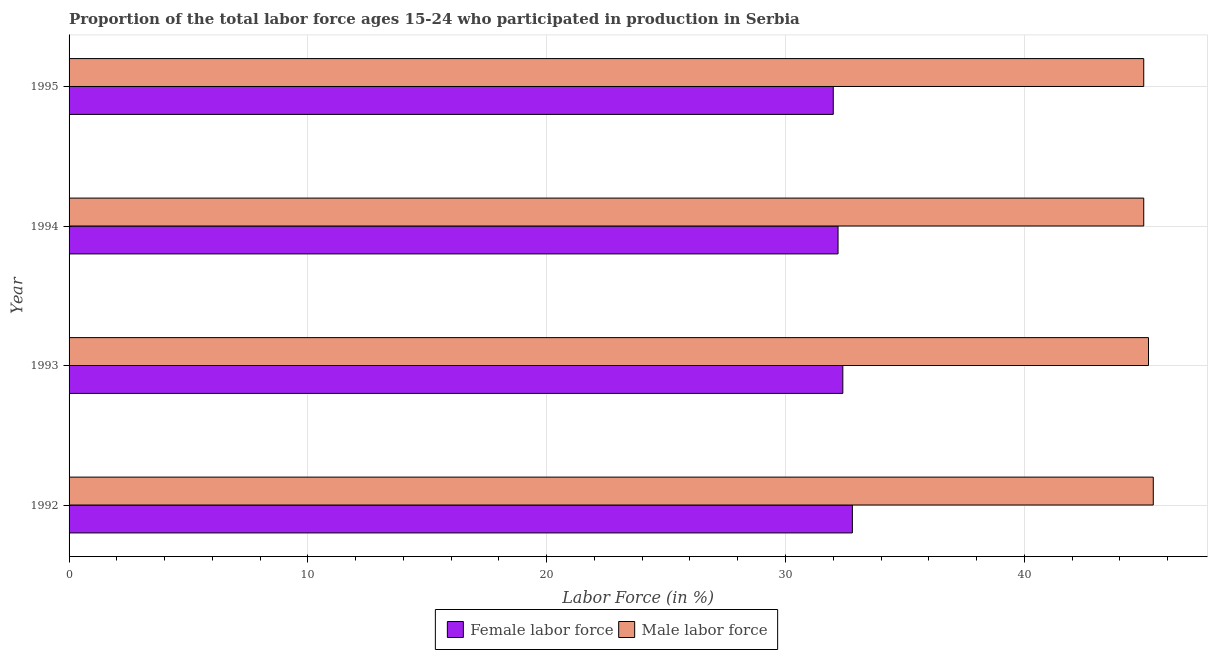How many groups of bars are there?
Keep it short and to the point. 4. Are the number of bars on each tick of the Y-axis equal?
Provide a succinct answer. Yes. How many bars are there on the 1st tick from the top?
Provide a short and direct response. 2. What is the percentage of male labour force in 1995?
Keep it short and to the point. 45. Across all years, what is the maximum percentage of female labor force?
Give a very brief answer. 32.8. Across all years, what is the minimum percentage of male labour force?
Ensure brevity in your answer.  45. What is the total percentage of male labour force in the graph?
Offer a terse response. 180.6. What is the difference between the percentage of male labour force in 1993 and that in 1994?
Your answer should be compact. 0.2. What is the difference between the percentage of female labor force in 1992 and the percentage of male labour force in 1995?
Provide a short and direct response. -12.2. What is the average percentage of female labor force per year?
Your answer should be compact. 32.35. In the year 1994, what is the difference between the percentage of female labor force and percentage of male labour force?
Your answer should be compact. -12.8. In how many years, is the percentage of male labour force greater than 10 %?
Ensure brevity in your answer.  4. Is the difference between the percentage of male labour force in 1994 and 1995 greater than the difference between the percentage of female labor force in 1994 and 1995?
Your answer should be very brief. No. What is the difference between the highest and the second highest percentage of female labor force?
Your answer should be very brief. 0.4. In how many years, is the percentage of male labour force greater than the average percentage of male labour force taken over all years?
Your answer should be compact. 2. What does the 1st bar from the top in 1995 represents?
Provide a short and direct response. Male labor force. What does the 1st bar from the bottom in 1995 represents?
Ensure brevity in your answer.  Female labor force. Are all the bars in the graph horizontal?
Your response must be concise. Yes. How many years are there in the graph?
Give a very brief answer. 4. Are the values on the major ticks of X-axis written in scientific E-notation?
Offer a terse response. No. Does the graph contain any zero values?
Your answer should be very brief. No. How many legend labels are there?
Provide a succinct answer. 2. What is the title of the graph?
Offer a very short reply. Proportion of the total labor force ages 15-24 who participated in production in Serbia. What is the label or title of the Y-axis?
Ensure brevity in your answer.  Year. What is the Labor Force (in %) of Female labor force in 1992?
Offer a terse response. 32.8. What is the Labor Force (in %) in Male labor force in 1992?
Provide a succinct answer. 45.4. What is the Labor Force (in %) of Female labor force in 1993?
Ensure brevity in your answer.  32.4. What is the Labor Force (in %) in Male labor force in 1993?
Your answer should be compact. 45.2. What is the Labor Force (in %) of Female labor force in 1994?
Your answer should be very brief. 32.2. What is the Labor Force (in %) in Male labor force in 1994?
Offer a terse response. 45. What is the Labor Force (in %) of Female labor force in 1995?
Offer a terse response. 32. Across all years, what is the maximum Labor Force (in %) in Female labor force?
Your answer should be compact. 32.8. Across all years, what is the maximum Labor Force (in %) in Male labor force?
Make the answer very short. 45.4. Across all years, what is the minimum Labor Force (in %) of Female labor force?
Offer a terse response. 32. Across all years, what is the minimum Labor Force (in %) of Male labor force?
Provide a short and direct response. 45. What is the total Labor Force (in %) in Female labor force in the graph?
Give a very brief answer. 129.4. What is the total Labor Force (in %) in Male labor force in the graph?
Provide a succinct answer. 180.6. What is the difference between the Labor Force (in %) in Male labor force in 1992 and that in 1993?
Provide a succinct answer. 0.2. What is the difference between the Labor Force (in %) of Male labor force in 1992 and that in 1994?
Keep it short and to the point. 0.4. What is the difference between the Labor Force (in %) of Male labor force in 1992 and that in 1995?
Provide a short and direct response. 0.4. What is the difference between the Labor Force (in %) of Male labor force in 1993 and that in 1994?
Provide a short and direct response. 0.2. What is the difference between the Labor Force (in %) in Female labor force in 1993 and that in 1995?
Your response must be concise. 0.4. What is the difference between the Labor Force (in %) in Female labor force in 1994 and that in 1995?
Provide a succinct answer. 0.2. What is the difference between the Labor Force (in %) in Female labor force in 1992 and the Labor Force (in %) in Male labor force in 1995?
Make the answer very short. -12.2. What is the difference between the Labor Force (in %) of Female labor force in 1993 and the Labor Force (in %) of Male labor force in 1995?
Ensure brevity in your answer.  -12.6. What is the difference between the Labor Force (in %) in Female labor force in 1994 and the Labor Force (in %) in Male labor force in 1995?
Keep it short and to the point. -12.8. What is the average Labor Force (in %) in Female labor force per year?
Offer a terse response. 32.35. What is the average Labor Force (in %) in Male labor force per year?
Your response must be concise. 45.15. In the year 1993, what is the difference between the Labor Force (in %) in Female labor force and Labor Force (in %) in Male labor force?
Provide a succinct answer. -12.8. In the year 1994, what is the difference between the Labor Force (in %) of Female labor force and Labor Force (in %) of Male labor force?
Your answer should be very brief. -12.8. What is the ratio of the Labor Force (in %) of Female labor force in 1992 to that in 1993?
Your answer should be compact. 1.01. What is the ratio of the Labor Force (in %) of Male labor force in 1992 to that in 1993?
Offer a terse response. 1. What is the ratio of the Labor Force (in %) in Female labor force in 1992 to that in 1994?
Your answer should be very brief. 1.02. What is the ratio of the Labor Force (in %) in Male labor force in 1992 to that in 1994?
Make the answer very short. 1.01. What is the ratio of the Labor Force (in %) of Female labor force in 1992 to that in 1995?
Offer a terse response. 1.02. What is the ratio of the Labor Force (in %) in Male labor force in 1992 to that in 1995?
Provide a short and direct response. 1.01. What is the ratio of the Labor Force (in %) in Female labor force in 1993 to that in 1994?
Offer a terse response. 1.01. What is the ratio of the Labor Force (in %) of Female labor force in 1993 to that in 1995?
Give a very brief answer. 1.01. What is the ratio of the Labor Force (in %) in Female labor force in 1994 to that in 1995?
Ensure brevity in your answer.  1.01. What is the ratio of the Labor Force (in %) in Male labor force in 1994 to that in 1995?
Ensure brevity in your answer.  1. What is the difference between the highest and the second highest Labor Force (in %) of Female labor force?
Your answer should be compact. 0.4. What is the difference between the highest and the second highest Labor Force (in %) in Male labor force?
Make the answer very short. 0.2. What is the difference between the highest and the lowest Labor Force (in %) of Male labor force?
Your response must be concise. 0.4. 